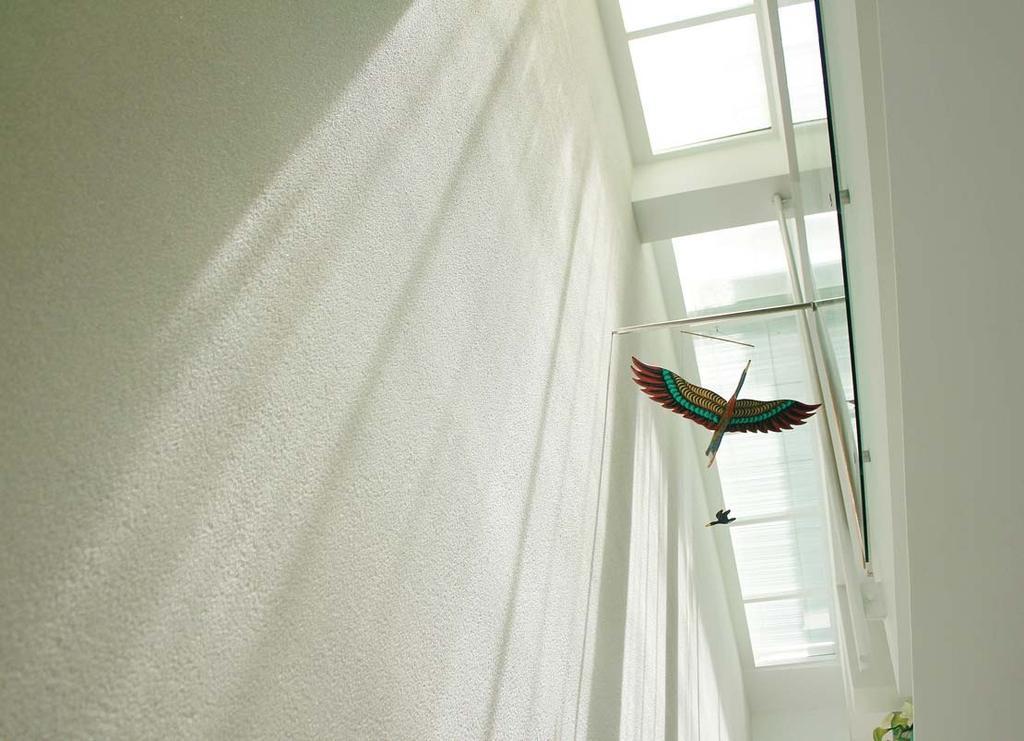Describe this image in one or two sentences. On the left side there is a wall. On the wall there are toy birds hanged. At the top there are glass walls. On the right side there is a wall. Also there is glass wall. At the bottom right corner there is a plant. 